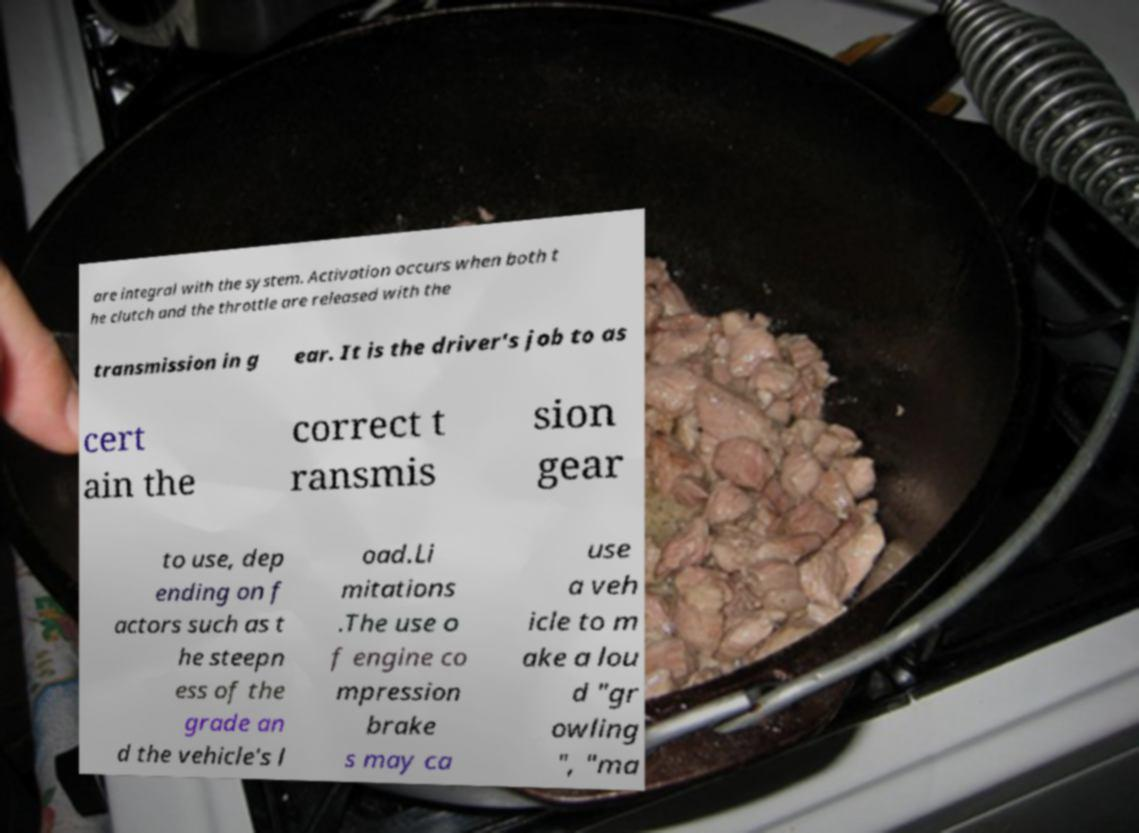I need the written content from this picture converted into text. Can you do that? are integral with the system. Activation occurs when both t he clutch and the throttle are released with the transmission in g ear. It is the driver's job to as cert ain the correct t ransmis sion gear to use, dep ending on f actors such as t he steepn ess of the grade an d the vehicle's l oad.Li mitations .The use o f engine co mpression brake s may ca use a veh icle to m ake a lou d "gr owling ", "ma 